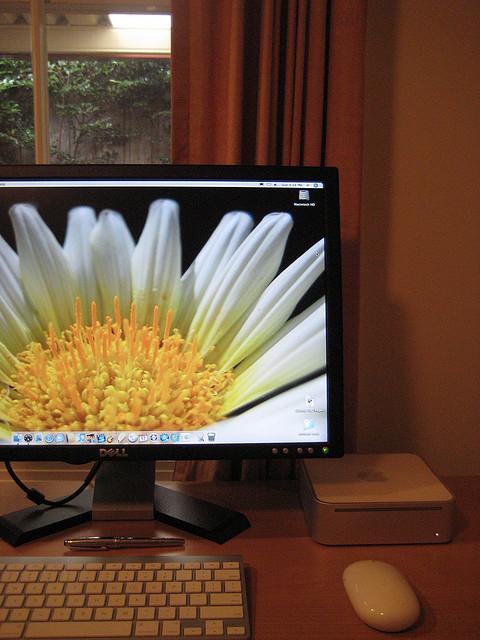What is the main color of the flower?
Write a very short answer. White. Where is the flower at?
Quick response, please. Monitor. What color is the flower?
Concise answer only. White. What is the object that holds the flowers?
Answer briefly. Screen. Is this flower in a pot?
Write a very short answer. No. What color is the wall?
Be succinct. Brown. Is the tv on?
Write a very short answer. Yes. 